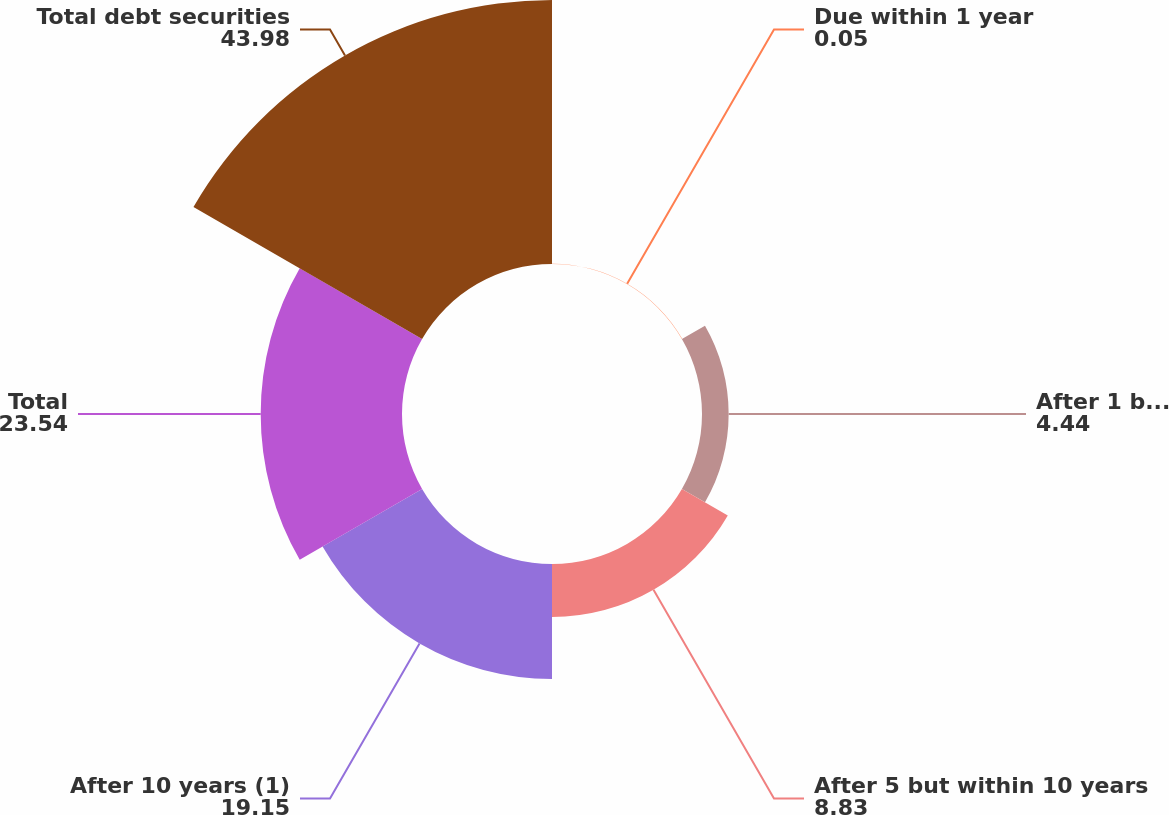<chart> <loc_0><loc_0><loc_500><loc_500><pie_chart><fcel>Due within 1 year<fcel>After 1 but within 5 years<fcel>After 5 but within 10 years<fcel>After 10 years (1)<fcel>Total<fcel>Total debt securities<nl><fcel>0.05%<fcel>4.44%<fcel>8.83%<fcel>19.15%<fcel>23.54%<fcel>43.98%<nl></chart> 